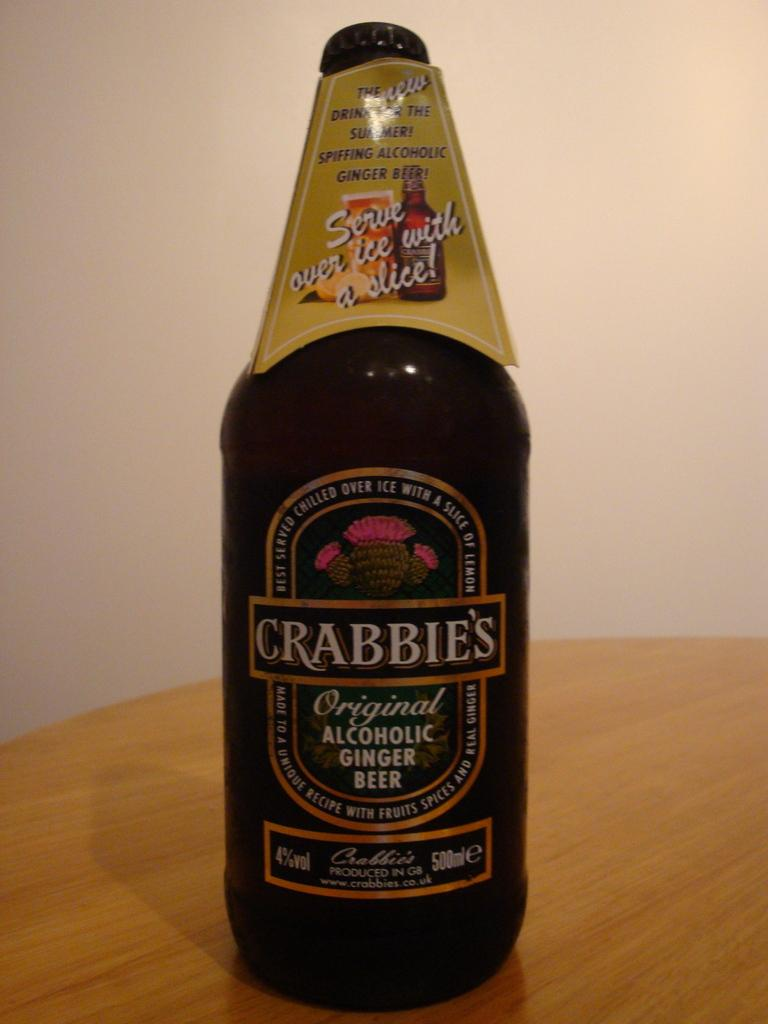<image>
Present a compact description of the photo's key features. Bottle of Crabbies Original Alcholic Ginger Beer drink on a table. 